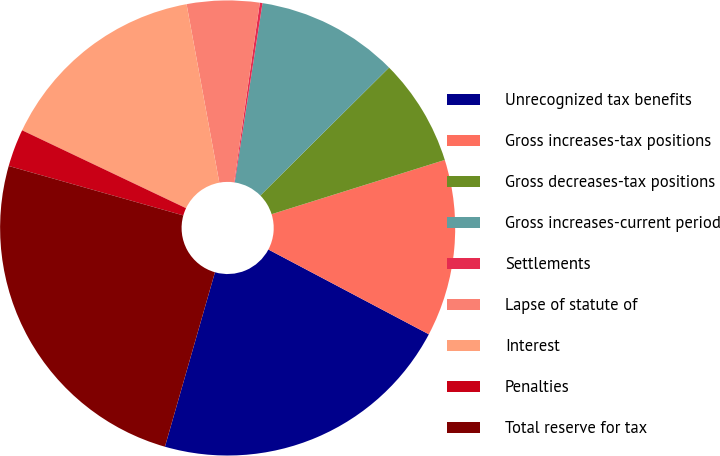<chart> <loc_0><loc_0><loc_500><loc_500><pie_chart><fcel>Unrecognized tax benefits<fcel>Gross increases-tax positions<fcel>Gross decreases-tax positions<fcel>Gross increases-current period<fcel>Settlements<fcel>Lapse of statute of<fcel>Interest<fcel>Penalties<fcel>Total reserve for tax<nl><fcel>21.71%<fcel>12.57%<fcel>7.62%<fcel>10.1%<fcel>0.19%<fcel>5.15%<fcel>15.05%<fcel>2.67%<fcel>24.95%<nl></chart> 